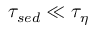Convert formula to latex. <formula><loc_0><loc_0><loc_500><loc_500>\tau _ { s e d } \ll \tau _ { \eta }</formula> 